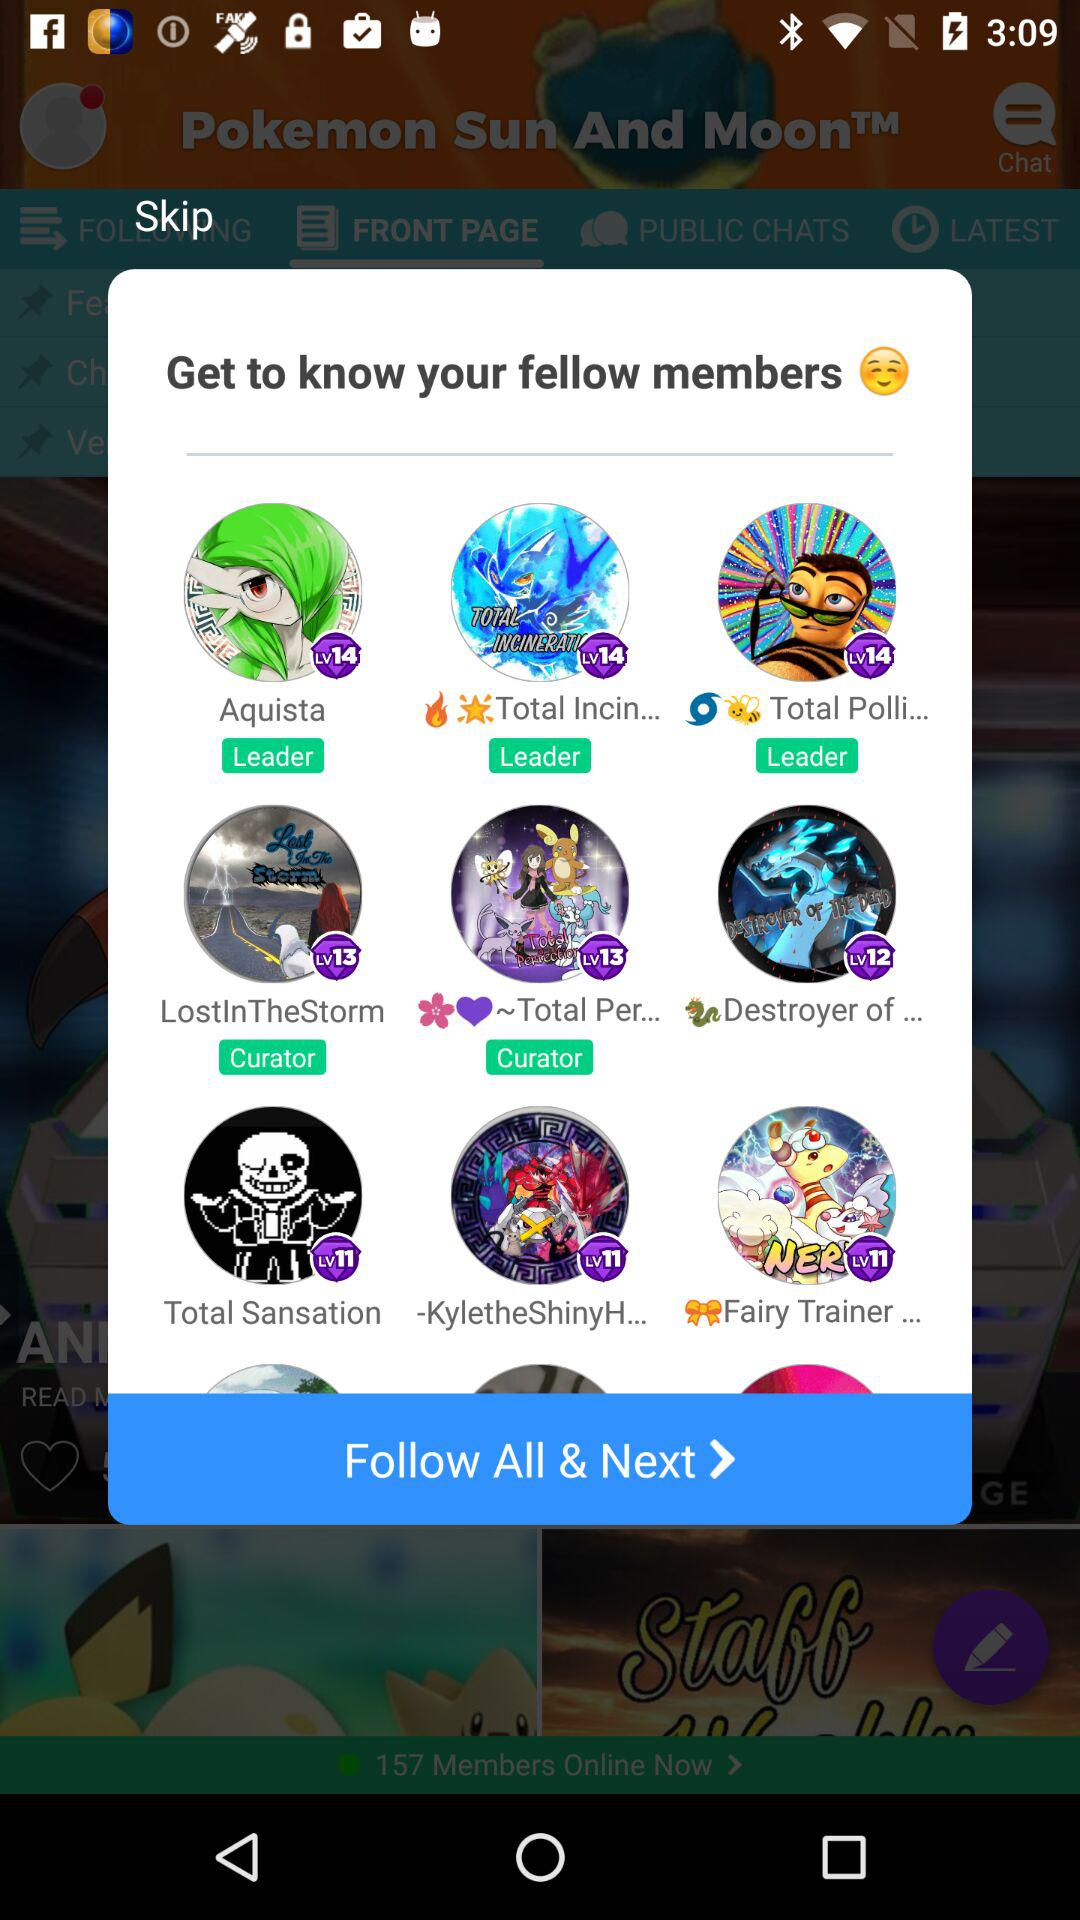How many members have the title of Leader?
Answer the question using a single word or phrase. 3 